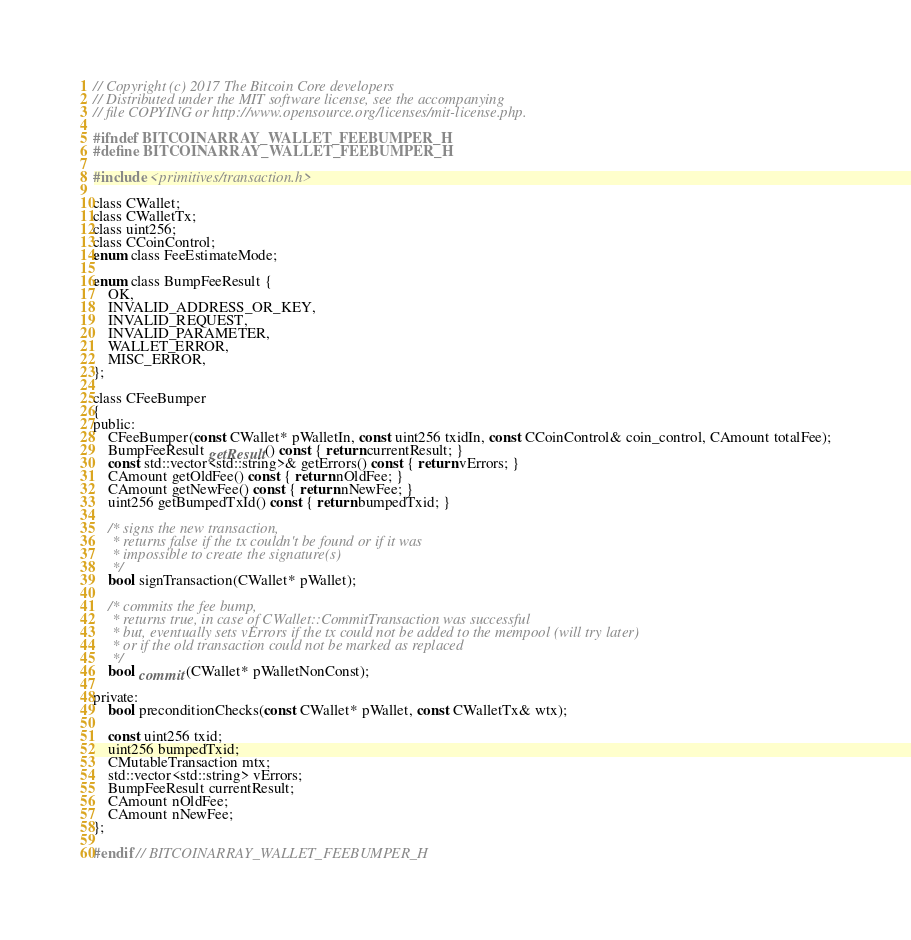<code> <loc_0><loc_0><loc_500><loc_500><_C_>// Copyright (c) 2017 The Bitcoin Core developers
// Distributed under the MIT software license, see the accompanying
// file COPYING or http://www.opensource.org/licenses/mit-license.php.

#ifndef BITCOINARRAY_WALLET_FEEBUMPER_H
#define BITCOINARRAY_WALLET_FEEBUMPER_H

#include <primitives/transaction.h>

class CWallet;
class CWalletTx;
class uint256;
class CCoinControl;
enum class FeeEstimateMode;

enum class BumpFeeResult {
    OK,
    INVALID_ADDRESS_OR_KEY,
    INVALID_REQUEST,
    INVALID_PARAMETER,
    WALLET_ERROR,
    MISC_ERROR,
};

class CFeeBumper
{
public:
    CFeeBumper(const CWallet* pWalletIn, const uint256 txidIn, const CCoinControl& coin_control, CAmount totalFee);
    BumpFeeResult getResult() const { return currentResult; }
    const std::vector<std::string>& getErrors() const { return vErrors; }
    CAmount getOldFee() const { return nOldFee; }
    CAmount getNewFee() const { return nNewFee; }
    uint256 getBumpedTxId() const { return bumpedTxid; }

    /* signs the new transaction,
     * returns false if the tx couldn't be found or if it was
     * impossible to create the signature(s)
     */
    bool signTransaction(CWallet* pWallet);

    /* commits the fee bump,
     * returns true, in case of CWallet::CommitTransaction was successful
     * but, eventually sets vErrors if the tx could not be added to the mempool (will try later)
     * or if the old transaction could not be marked as replaced
     */
    bool commit(CWallet* pWalletNonConst);

private:
    bool preconditionChecks(const CWallet* pWallet, const CWalletTx& wtx);

    const uint256 txid;
    uint256 bumpedTxid;
    CMutableTransaction mtx;
    std::vector<std::string> vErrors;
    BumpFeeResult currentResult;
    CAmount nOldFee;
    CAmount nNewFee;
};

#endif // BITCOINARRAY_WALLET_FEEBUMPER_H
</code> 